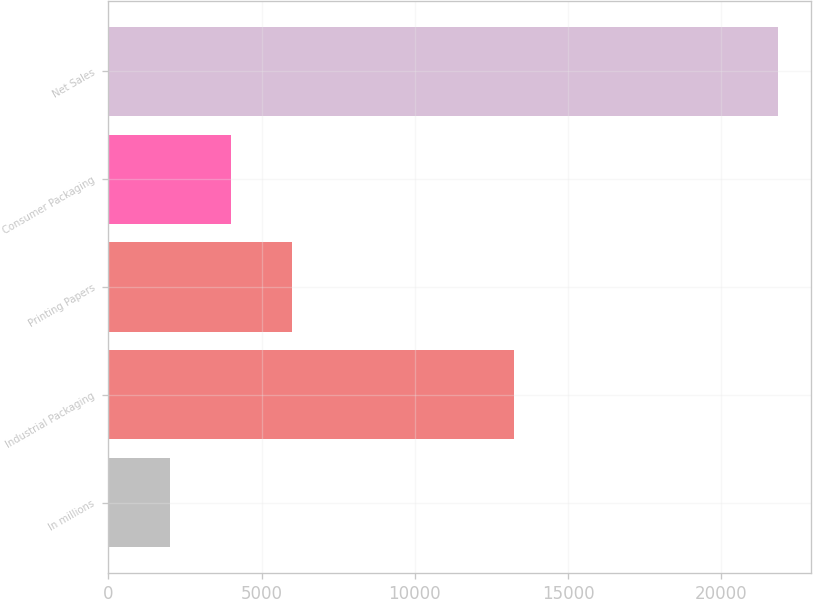Convert chart. <chart><loc_0><loc_0><loc_500><loc_500><bar_chart><fcel>In millions<fcel>Industrial Packaging<fcel>Printing Papers<fcel>Consumer Packaging<fcel>Net Sales<nl><fcel>2012<fcel>13223<fcel>5980<fcel>3996<fcel>21852<nl></chart> 